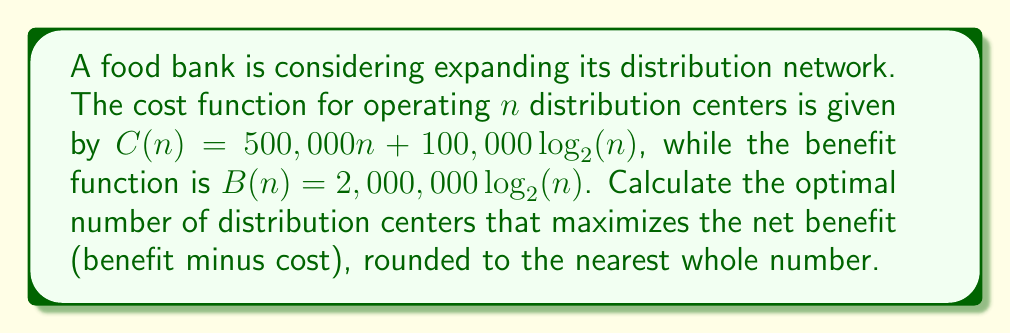Give your solution to this math problem. 1) The net benefit function is given by:
   $NB(n) = B(n) - C(n)$
   $NB(n) = 2,000,000\log_2(n) - (500,000n + 100,000\log_2(n))$
   $NB(n) = 1,900,000\log_2(n) - 500,000n$

2) To find the maximum, we differentiate $NB(n)$ with respect to $n$ and set it to zero:
   $$\frac{d}{dn}NB(n) = \frac{1,900,000}{\ln(2) \cdot n} - 500,000 = 0$$

3) Solving for $n$:
   $$\frac{1,900,000}{\ln(2) \cdot n} = 500,000$$
   $$n = \frac{1,900,000}{500,000 \cdot \ln(2)}$$
   $$n \approx 5.48$$

4) Rounding to the nearest whole number:
   $n = 5$ distribution centers

5) To verify this is a maximum, we can check the second derivative is negative:
   $$\frac{d^2}{dn^2}NB(n) = -\frac{1,900,000}{\ln(2) \cdot n^2} < 0$$
   This confirms we have found a maximum.
Answer: 5 distribution centers 